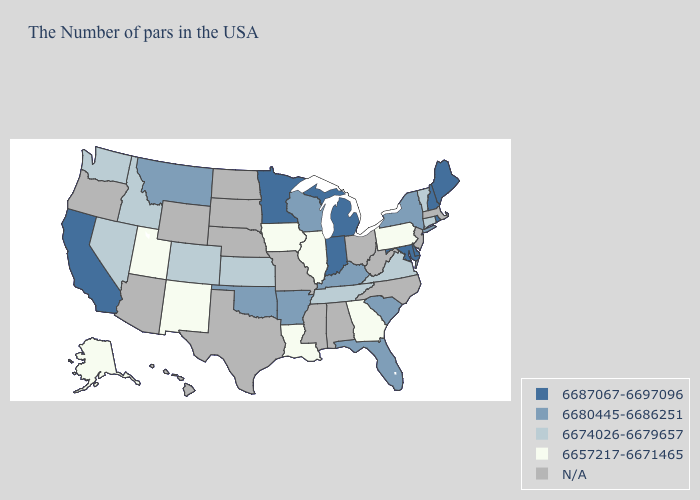Does Tennessee have the lowest value in the South?
Short answer required. No. What is the value of Missouri?
Concise answer only. N/A. What is the highest value in states that border Indiana?
Give a very brief answer. 6687067-6697096. Does the map have missing data?
Be succinct. Yes. What is the value of Georgia?
Write a very short answer. 6657217-6671465. Which states have the lowest value in the USA?
Answer briefly. Pennsylvania, Georgia, Illinois, Louisiana, Iowa, New Mexico, Utah, Alaska. What is the highest value in the South ?
Write a very short answer. 6687067-6697096. What is the value of Ohio?
Concise answer only. N/A. Name the states that have a value in the range 6687067-6697096?
Keep it brief. Maine, Rhode Island, New Hampshire, Delaware, Maryland, Michigan, Indiana, Minnesota, California. Does Alaska have the lowest value in the West?
Answer briefly. Yes. What is the value of Kansas?
Keep it brief. 6674026-6679657. What is the highest value in the USA?
Give a very brief answer. 6687067-6697096. Name the states that have a value in the range N/A?
Short answer required. Massachusetts, New Jersey, North Carolina, West Virginia, Ohio, Alabama, Mississippi, Missouri, Nebraska, Texas, South Dakota, North Dakota, Wyoming, Arizona, Oregon, Hawaii. 